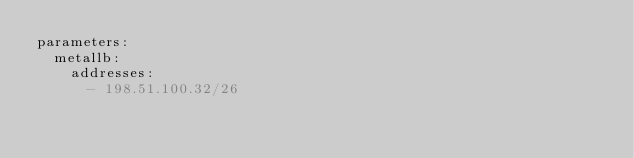Convert code to text. <code><loc_0><loc_0><loc_500><loc_500><_YAML_>parameters:
  metallb:
    addresses:
      - 198.51.100.32/26
</code> 